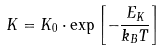Convert formula to latex. <formula><loc_0><loc_0><loc_500><loc_500>K = K _ { 0 } \cdot \exp { \left [ - \frac { E _ { K } } { k _ { B } T } \right ] }</formula> 